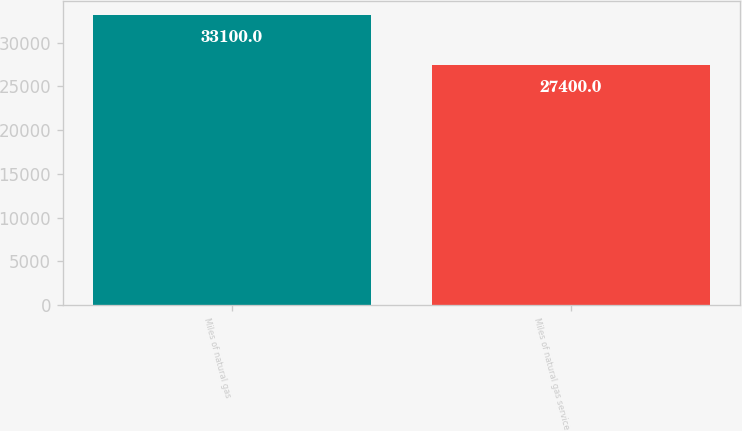Convert chart. <chart><loc_0><loc_0><loc_500><loc_500><bar_chart><fcel>Miles of natural gas<fcel>Miles of natural gas service<nl><fcel>33100<fcel>27400<nl></chart> 